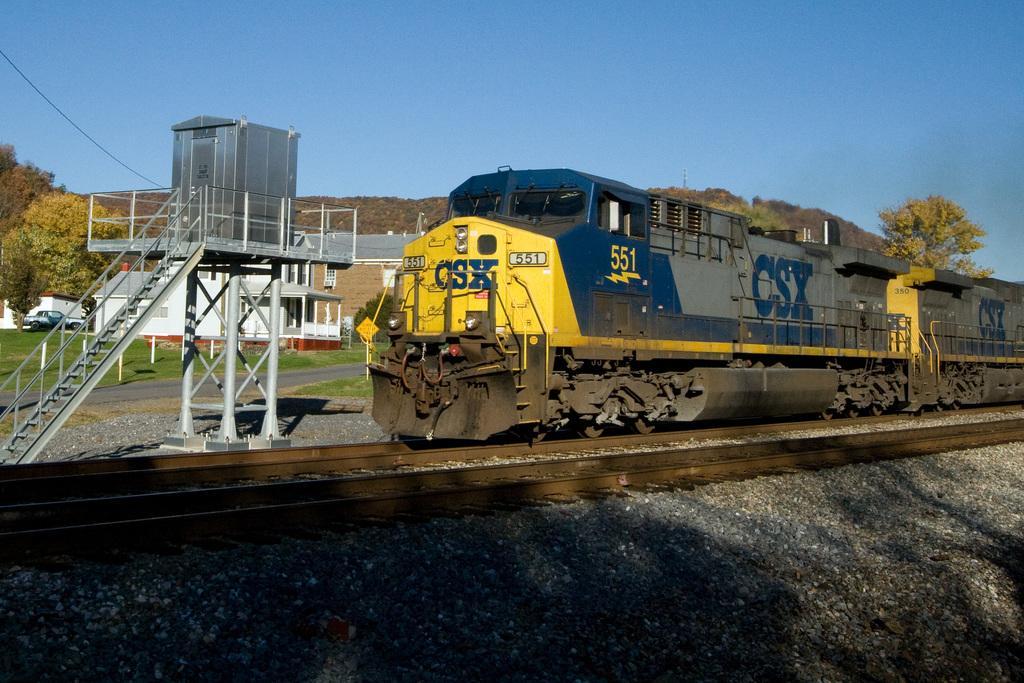Could you give a brief overview of what you see in this image? In this picture there is a train on the right side of the image on the tracks and there are pebbles at the bottom side of the image and there are houses, trees, and a car in the background area of the image, there are stairs on the left side of the image. 